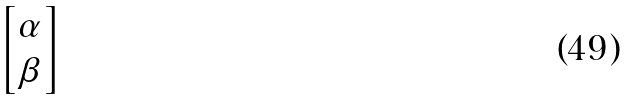Convert formula to latex. <formula><loc_0><loc_0><loc_500><loc_500>\begin{bmatrix} \alpha \\ \beta \end{bmatrix}</formula> 